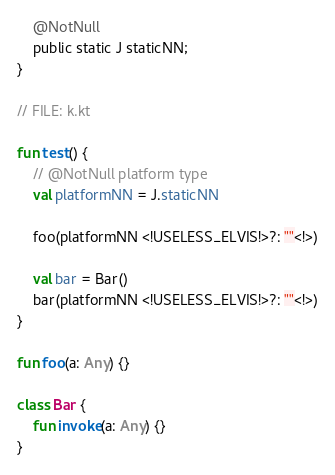<code> <loc_0><loc_0><loc_500><loc_500><_Kotlin_>    @NotNull
    public static J staticNN;
}

// FILE: k.kt

fun test() {
    // @NotNull platform type
    val platformNN = J.staticNN

    foo(platformNN <!USELESS_ELVIS!>?: ""<!>)

    val bar = Bar()
    bar(platformNN <!USELESS_ELVIS!>?: ""<!>)
}

fun foo(a: Any) {}

class Bar {
    fun invoke(a: Any) {}
}</code> 